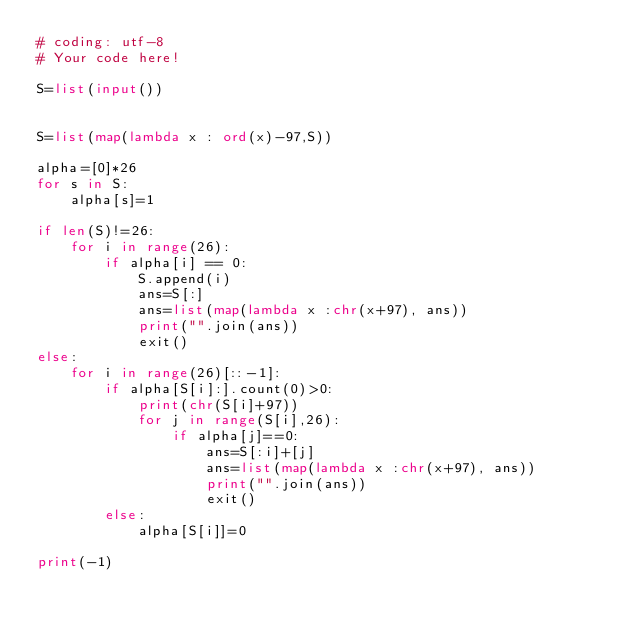<code> <loc_0><loc_0><loc_500><loc_500><_Python_># coding: utf-8
# Your code here!

S=list(input())


S=list(map(lambda x : ord(x)-97,S))

alpha=[0]*26
for s in S:
    alpha[s]=1

if len(S)!=26:
    for i in range(26):
        if alpha[i] == 0:
            S.append(i)
            ans=S[:]
            ans=list(map(lambda x :chr(x+97), ans))
            print("".join(ans))
            exit()
else:
    for i in range(26)[::-1]:
        if alpha[S[i]:].count(0)>0:
            print(chr(S[i]+97))
            for j in range(S[i],26):
                if alpha[j]==0:
                    ans=S[:i]+[j]
                    ans=list(map(lambda x :chr(x+97), ans))
                    print("".join(ans))
                    exit()
        else:
            alpha[S[i]]=0

print(-1)
</code> 